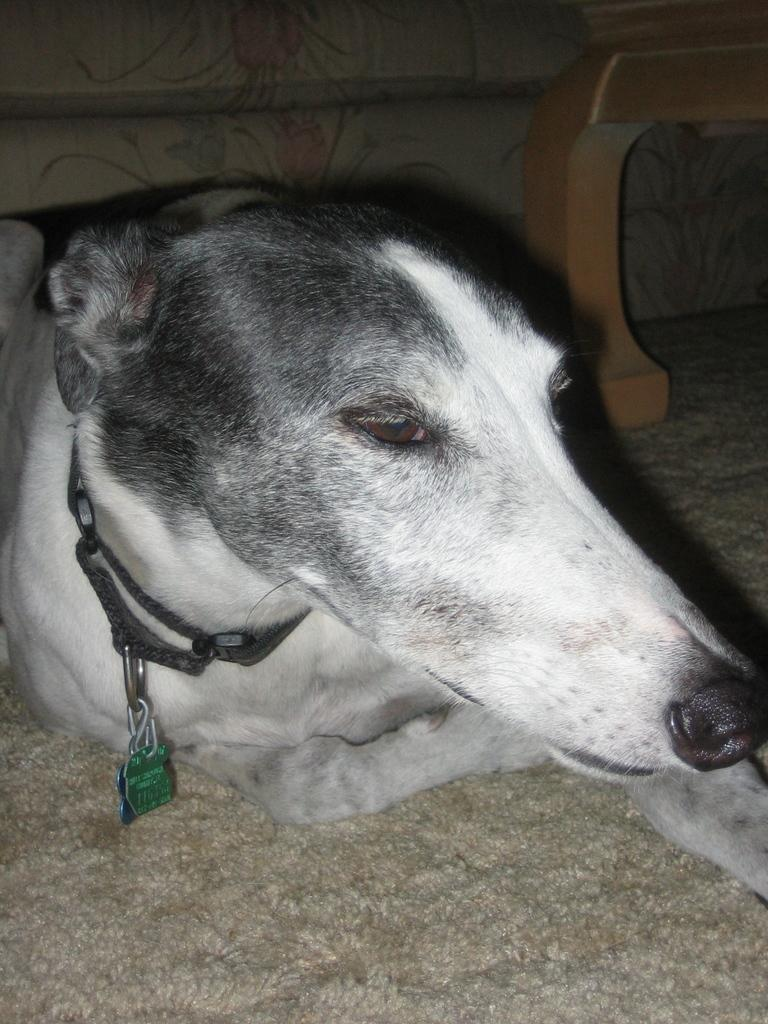What type of animal is on the floor in the image? There is a dog on the floor in the image. Can you describe the object in the image? Unfortunately, the facts provided do not give any details about the object in the image. What can be seen in the background of the image? There is a wall and a pipe in the background of the image. What type of wax can be seen melting on the dog's fur in the image? There is no wax present in the image, and the dog's fur does not appear to be melting. 